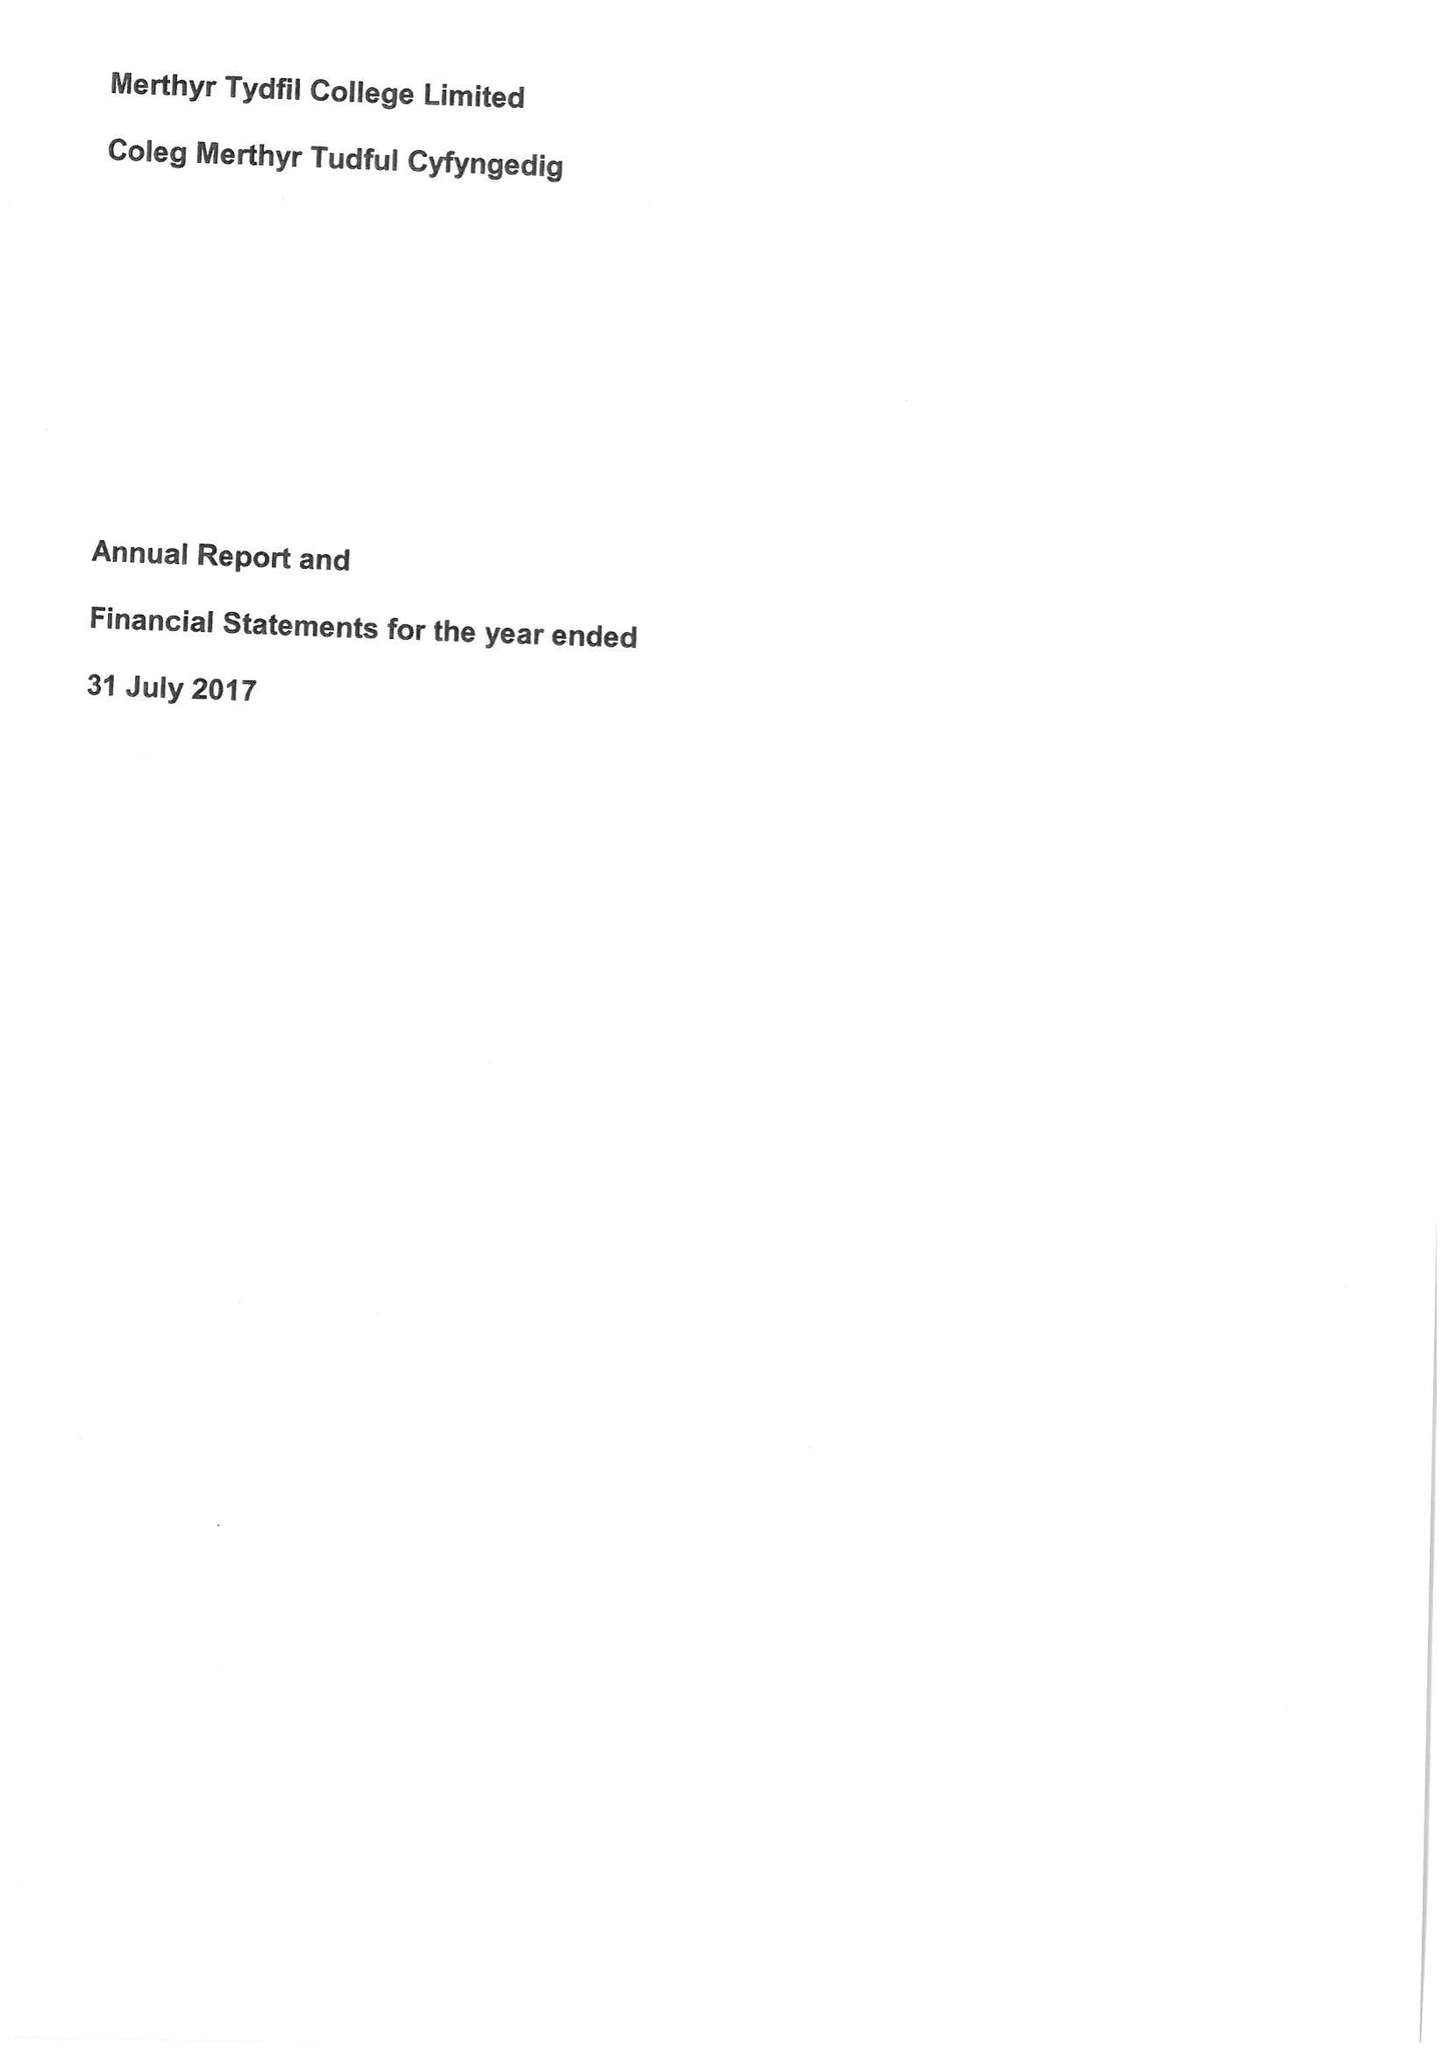What is the value for the spending_annually_in_british_pounds?
Answer the question using a single word or phrase. 13794000.00 